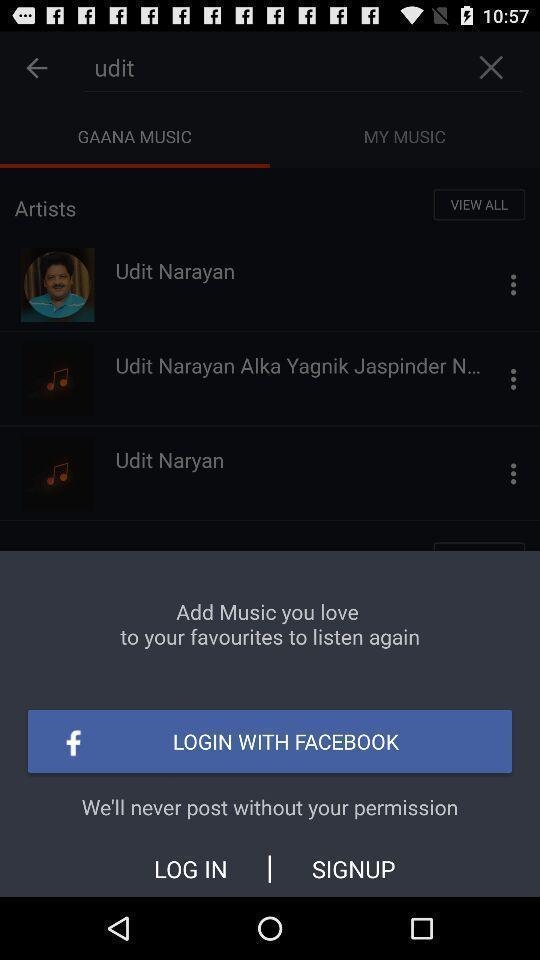What can you discern from this picture? Pop up asking to login with social app. 